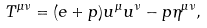<formula> <loc_0><loc_0><loc_500><loc_500>T ^ { \mu \nu } = ( e + p ) u ^ { \mu } u ^ { \nu } - p \eta ^ { \mu \nu } ,</formula> 